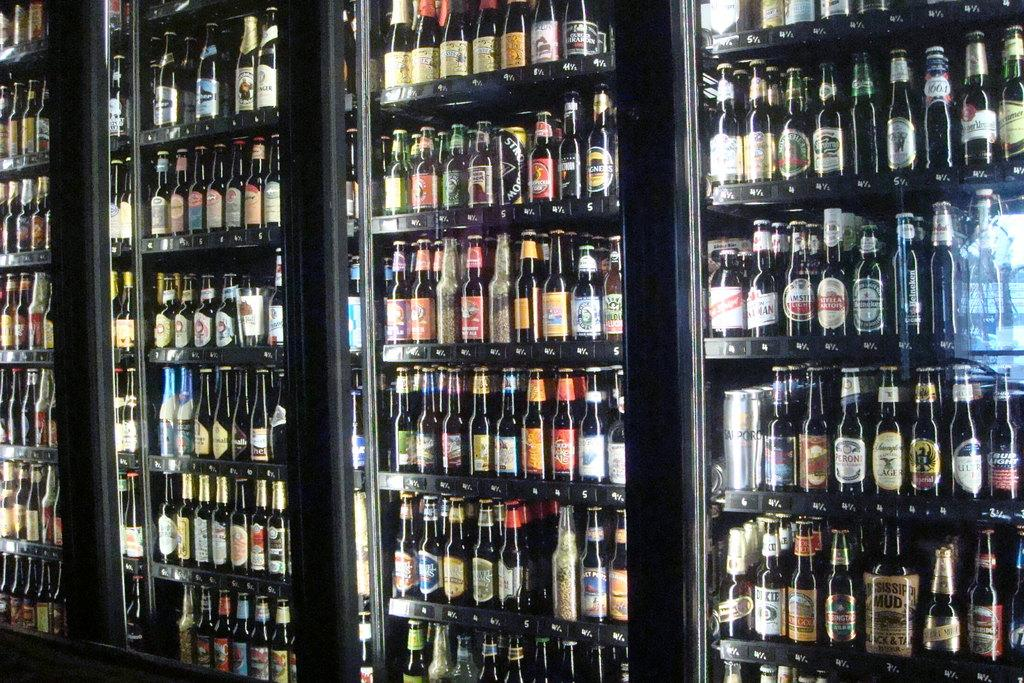What is the main object in the image? There is a wine rack in the image. What can be seen on the wine bottles? The wine bottles have colorful stickers. What is the color of the wine rack? The wine rack is black in color. How many clocks are hanging on the wine rack in the image? There are no clocks present in the image; it only features a wine rack with wine bottles. 